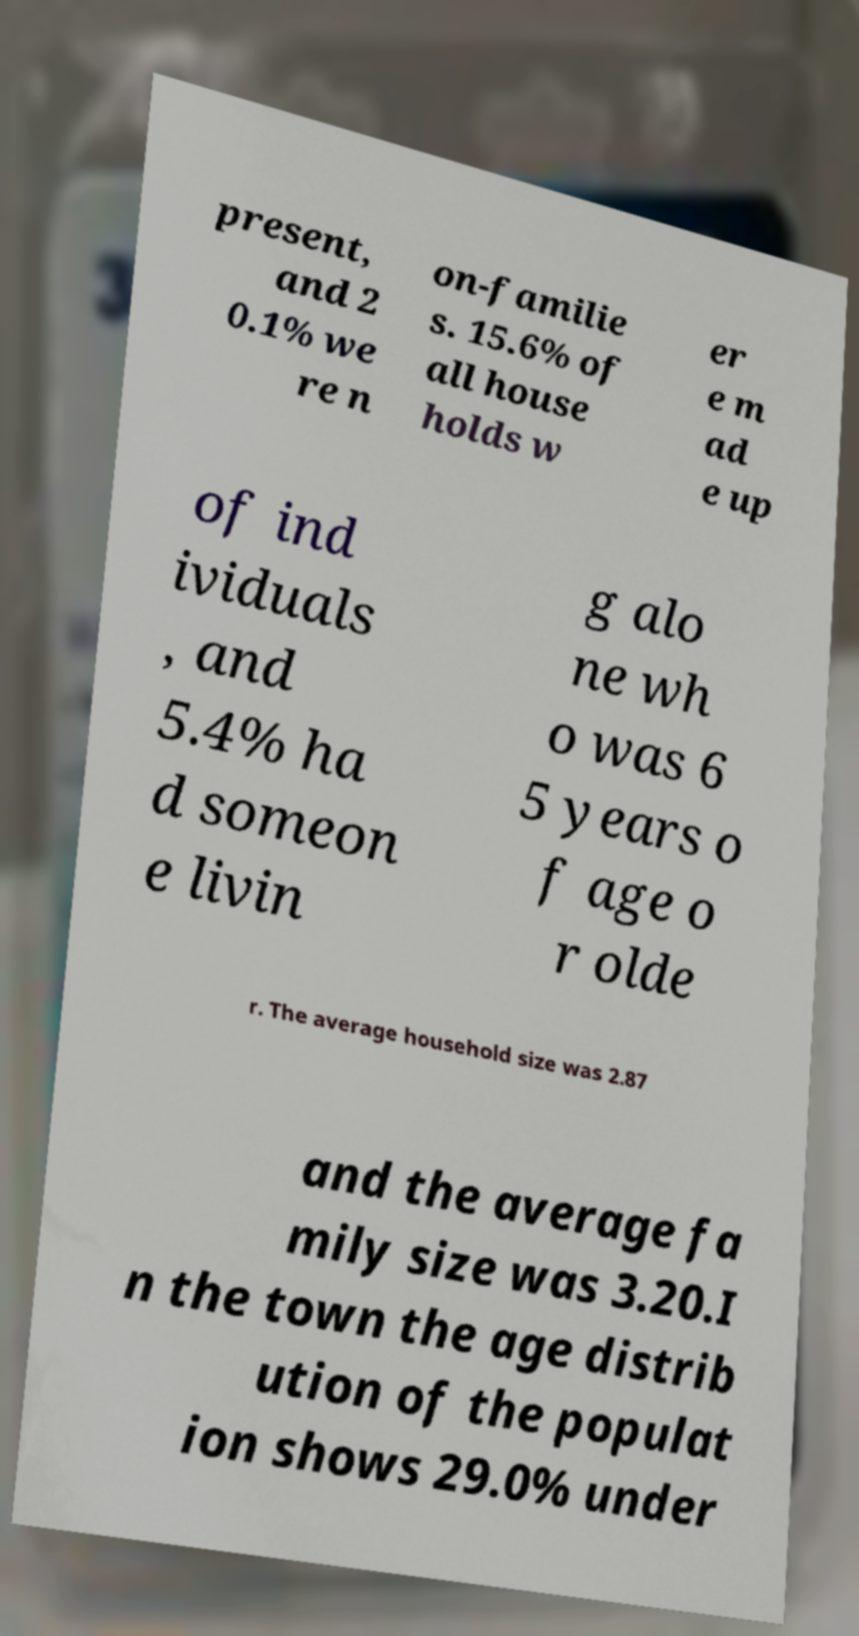Please read and relay the text visible in this image. What does it say? present, and 2 0.1% we re n on-familie s. 15.6% of all house holds w er e m ad e up of ind ividuals , and 5.4% ha d someon e livin g alo ne wh o was 6 5 years o f age o r olde r. The average household size was 2.87 and the average fa mily size was 3.20.I n the town the age distrib ution of the populat ion shows 29.0% under 